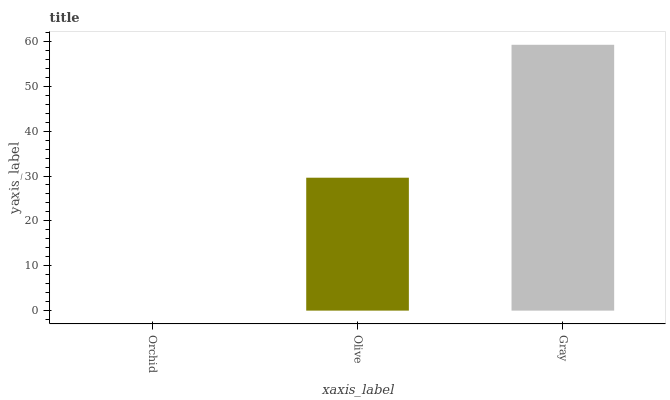Is Olive the minimum?
Answer yes or no. No. Is Olive the maximum?
Answer yes or no. No. Is Olive greater than Orchid?
Answer yes or no. Yes. Is Orchid less than Olive?
Answer yes or no. Yes. Is Orchid greater than Olive?
Answer yes or no. No. Is Olive less than Orchid?
Answer yes or no. No. Is Olive the high median?
Answer yes or no. Yes. Is Olive the low median?
Answer yes or no. Yes. Is Orchid the high median?
Answer yes or no. No. Is Orchid the low median?
Answer yes or no. No. 